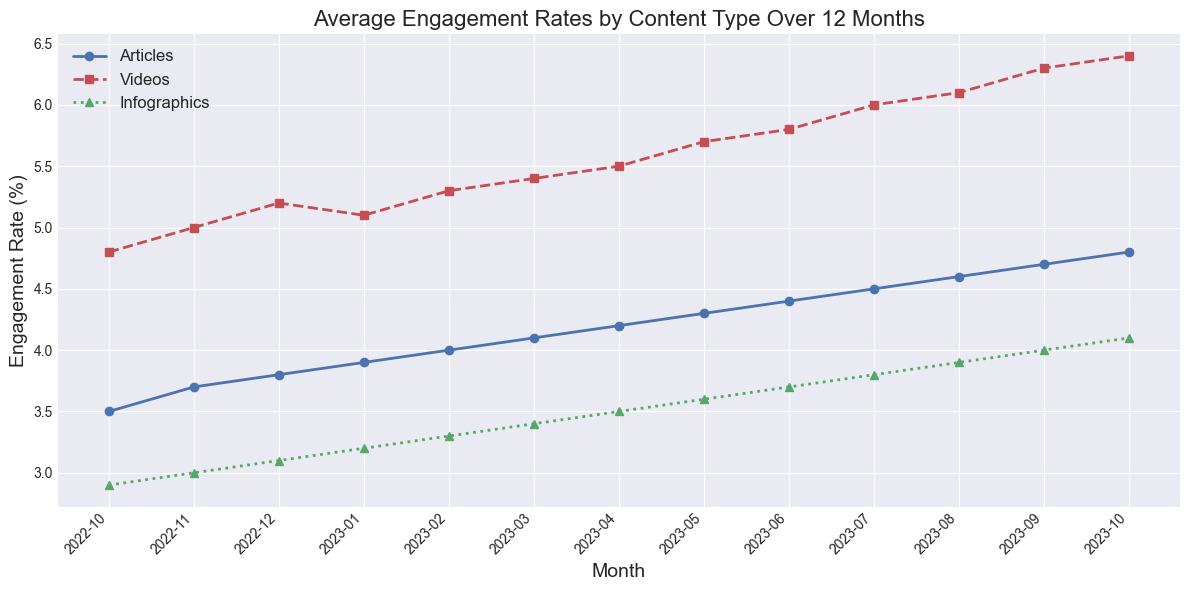What is the highest engagement rate recorded for articles over the 12-month period? By observing the plot line for articles (blue line), the highest engagement rate is at the last data point in October 2023.
Answer: 4.8% Which content type shows a consistently higher engagement rate throughout the period, videos or infographics? By comparing the red line (videos) and the green line (infographics), it is clear that the line for videos is always above the line for infographics, indicating higher engagement rates.
Answer: Videos In which month did all three content types have increasing engagement rates compared to the previous month? By examining each month's data point and comparing it to the previous month's, March 2023 shows that Articles increased from 4.0% to 4.1%, Videos from 5.3% to 5.4%, and Infographics from 3.3% to 3.4%.
Answer: March 2023 Calculate the average engagement rate for Videos and Infographics in May 2023. In May 2023, the engagement rate for Videos is 5.7% and for Infographics is 3.6%. The average is calculated as (5.7 + 3.6) / 2 = 4.65.
Answer: 4.65% Which month shows the smallest engagement rate difference between Articles and Videos? By comparing the differences of each month: the smallest difference is in January 2023 where Articles are 3.9% and Videos are 5.1%, the difference is 5.1 - 3.9 = 1.2.
Answer: January 2023 How does the trend of infographics' engagement rates compare to the trend of video engagement rates over the year? Both infographics (green line) and videos (red line) are showing an upward trend; however, the rate of increase is steeper for videos than for infographics.
Answer: Both are upward, videos steeper In which months did the engagement rate for articles exceed 4%? By observing the blue line, Articles exceed 4% in February 2023 and every month thereafter.
Answer: February 2023 to October 2023 Which content type had the most significant increase from the first to the last month? By comparing the start and end points for each line: articles increased from 3.5% to 4.8% (1.3%), videos from 4.8% to 6.4% (1.6%), infographics from 2.9% to 4.1% (1.2%), the most significant increase is in Videos.
Answer: Videos 